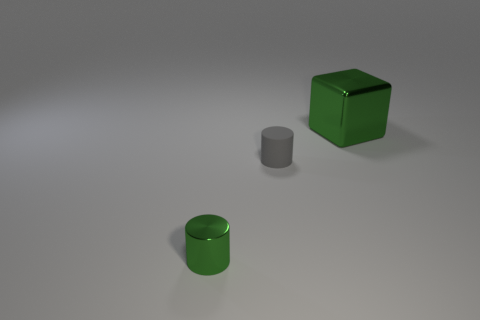Add 2 big gray cylinders. How many objects exist? 5 Subtract all cubes. How many objects are left? 2 Subtract all metal objects. Subtract all small green metal cylinders. How many objects are left? 0 Add 1 big green objects. How many big green objects are left? 2 Add 1 brown cylinders. How many brown cylinders exist? 1 Subtract 0 purple cylinders. How many objects are left? 3 Subtract all brown cylinders. Subtract all brown spheres. How many cylinders are left? 2 